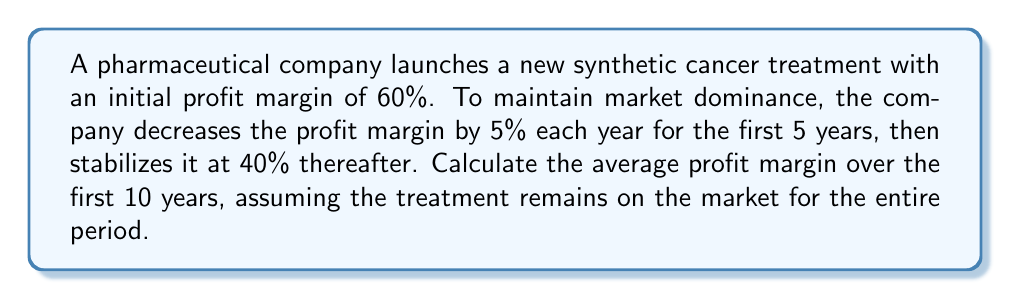Can you answer this question? Let's approach this step-by-step:

1) First, let's list out the profit margins for each year:
   Year 1: 60%
   Year 2: 55%
   Year 3: 50%
   Year 4: 45%
   Year 5: 40%
   Years 6-10: 40% each year

2) We can represent this as a sequence: $\{60, 55, 50, 45, 40, 40, 40, 40, 40, 40\}$

3) To find the average, we need to sum all these values and divide by the number of years:

   $$\text{Average} = \frac{\sum_{i=1}^{10} a_i}{10}$$

   where $a_i$ represents the profit margin in year $i$.

4) Let's calculate the sum:
   $$(60 + 55 + 50 + 45 + 40) + (40 \times 5) = 250 + 200 = 450$$

5) Now we can calculate the average:

   $$\text{Average} = \frac{450}{10} = 45$$

Therefore, the average profit margin over the first 10 years is 45%.
Answer: 45% 